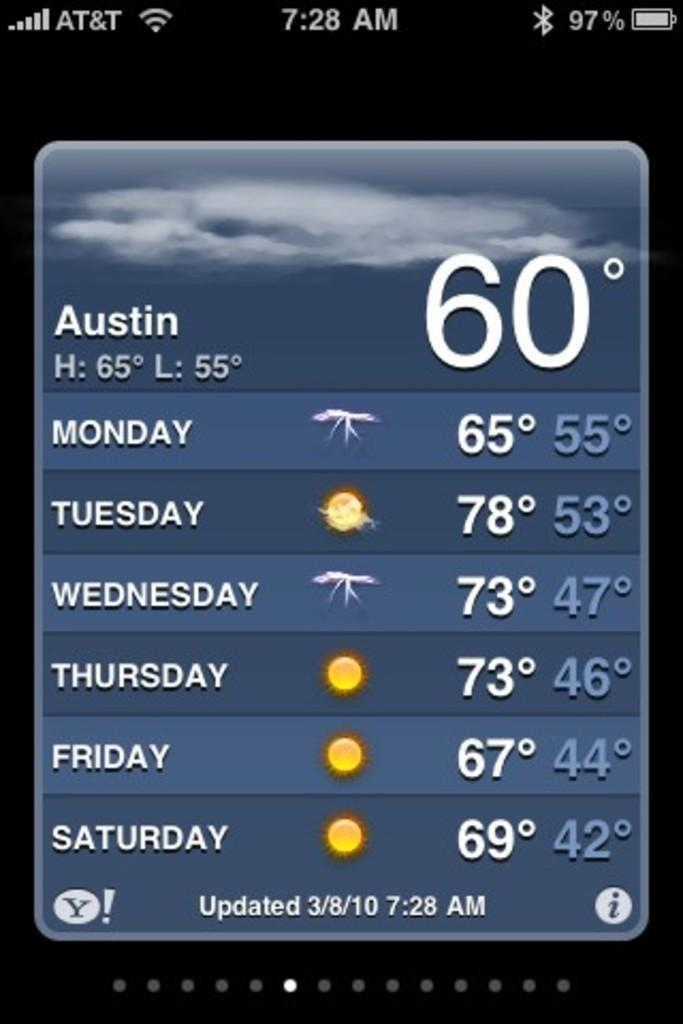<image>
Create a compact narrative representing the image presented. Phone screen that tells the temperature for Austin Texas. 